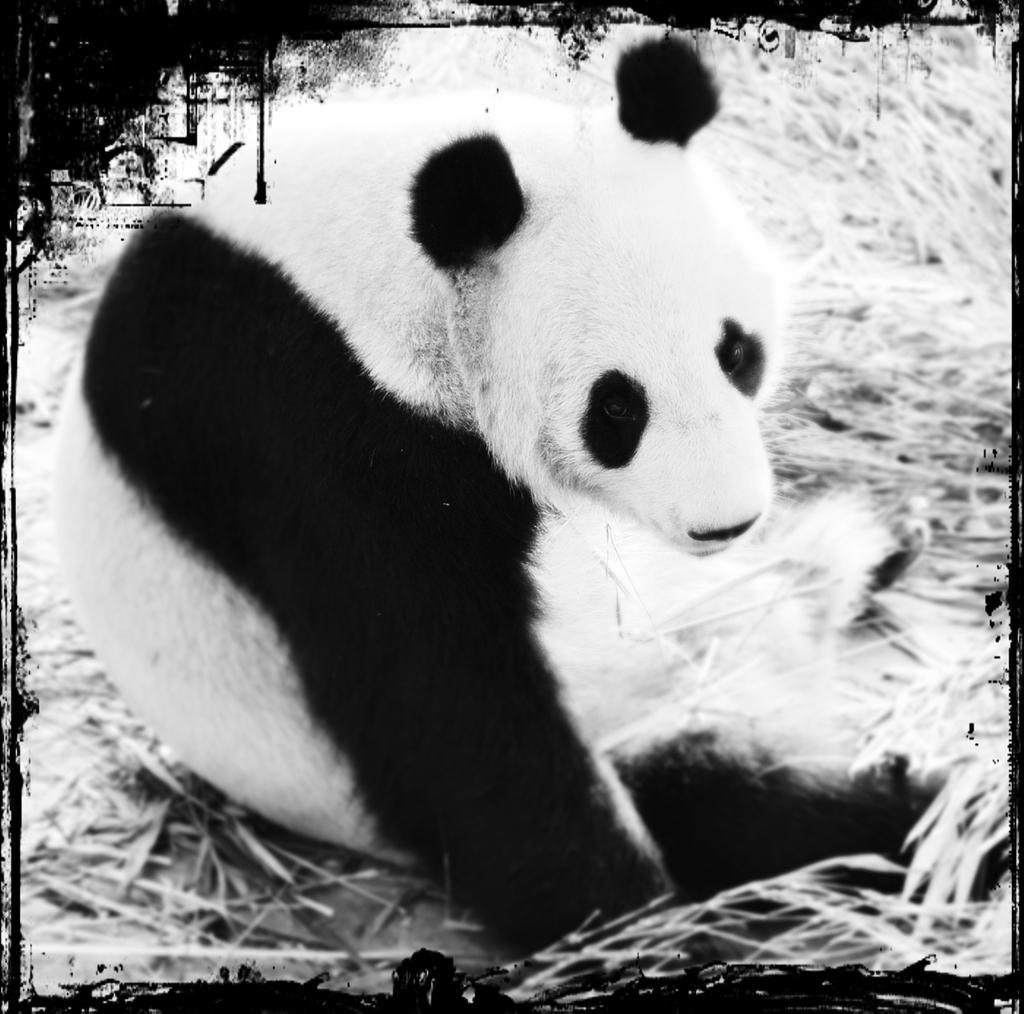What is the color scheme of the image? The image is black and white. What type of living creature can be seen in the image? There is an animal in the image. Where is the animal located in the image? The animal is on the ground. What type of vegetation is visible in the image? There is grass visible in the image. What type of pot is being worn by the animal in the image? There is no pot present in the image, and the animal is not wearing any clothing. How many people are in the crowd surrounding the animal in the image? There is no crowd present in the image; it only features an animal on the ground. 